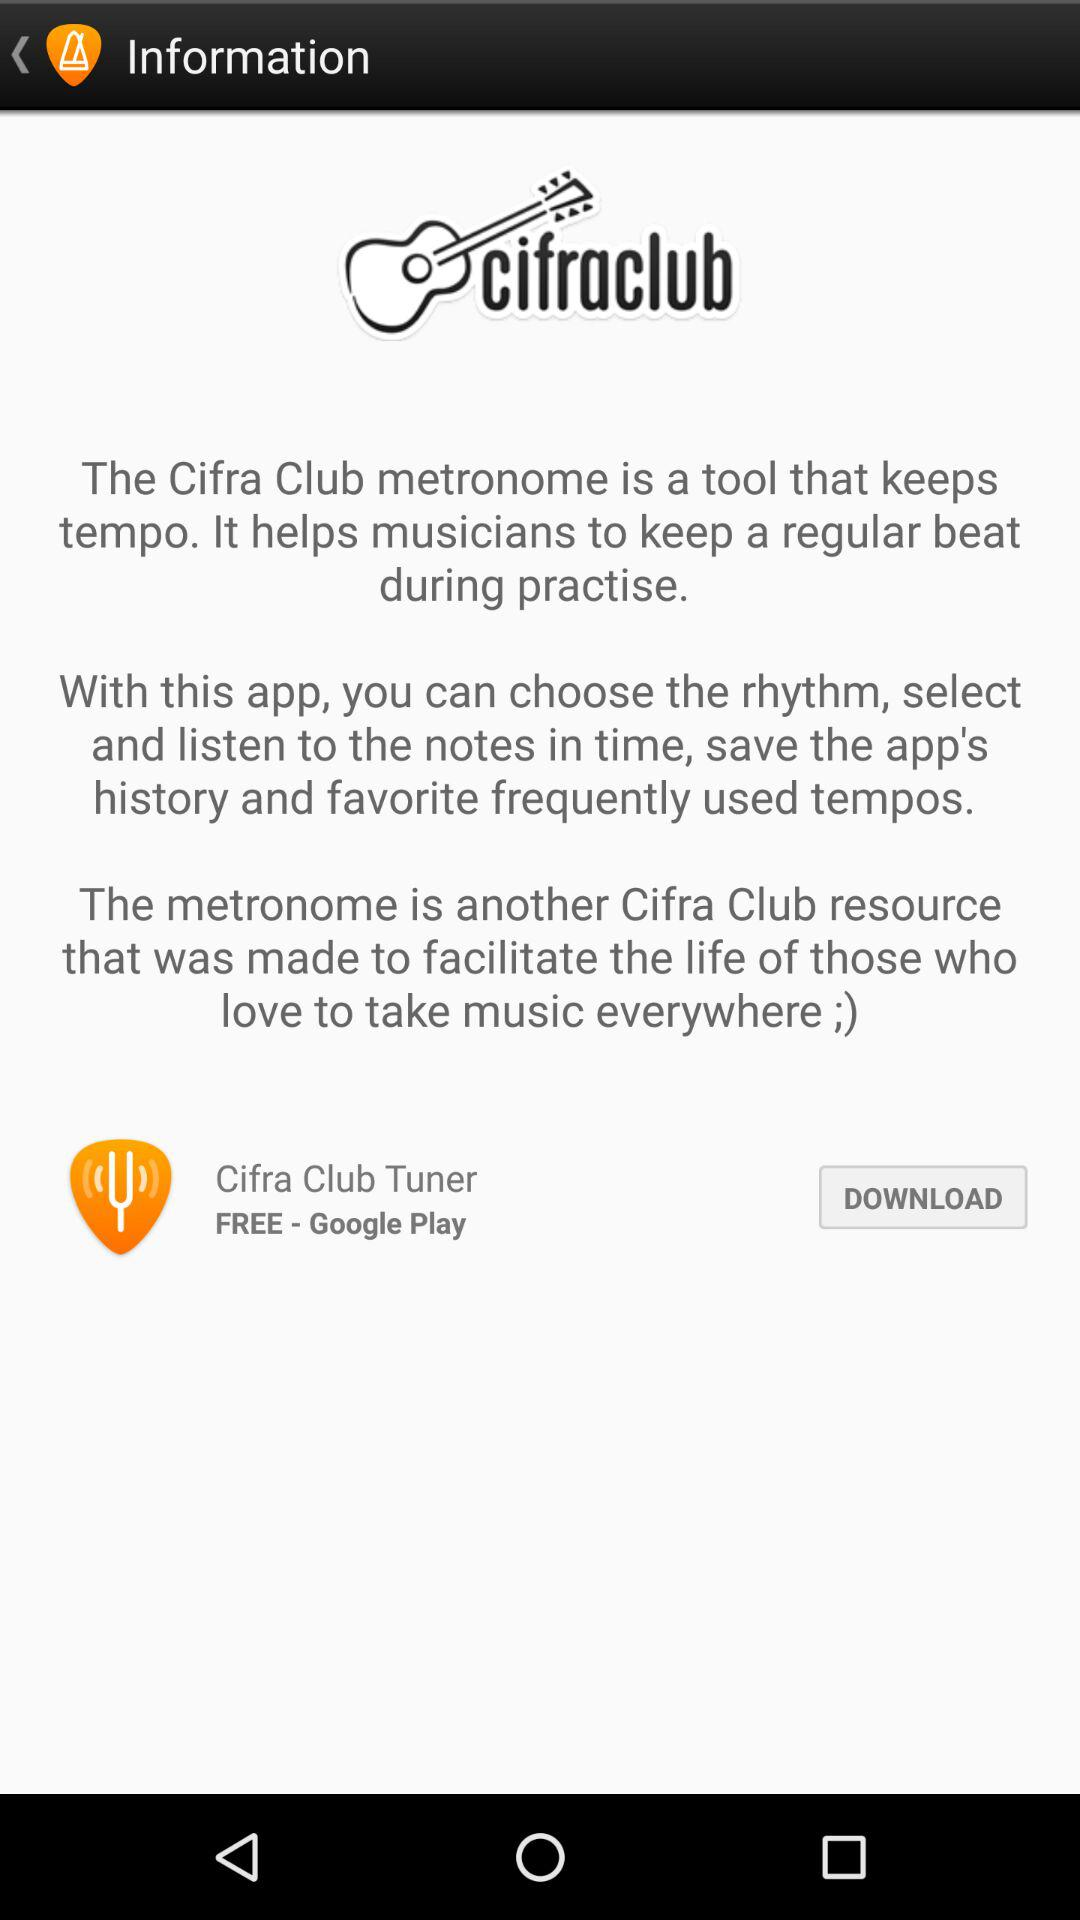What can we do with "Metronome Cifra Club"? You can choose the rhythm, select and listen to the notes in time, save the app's history and favorite frequently used tempos. 